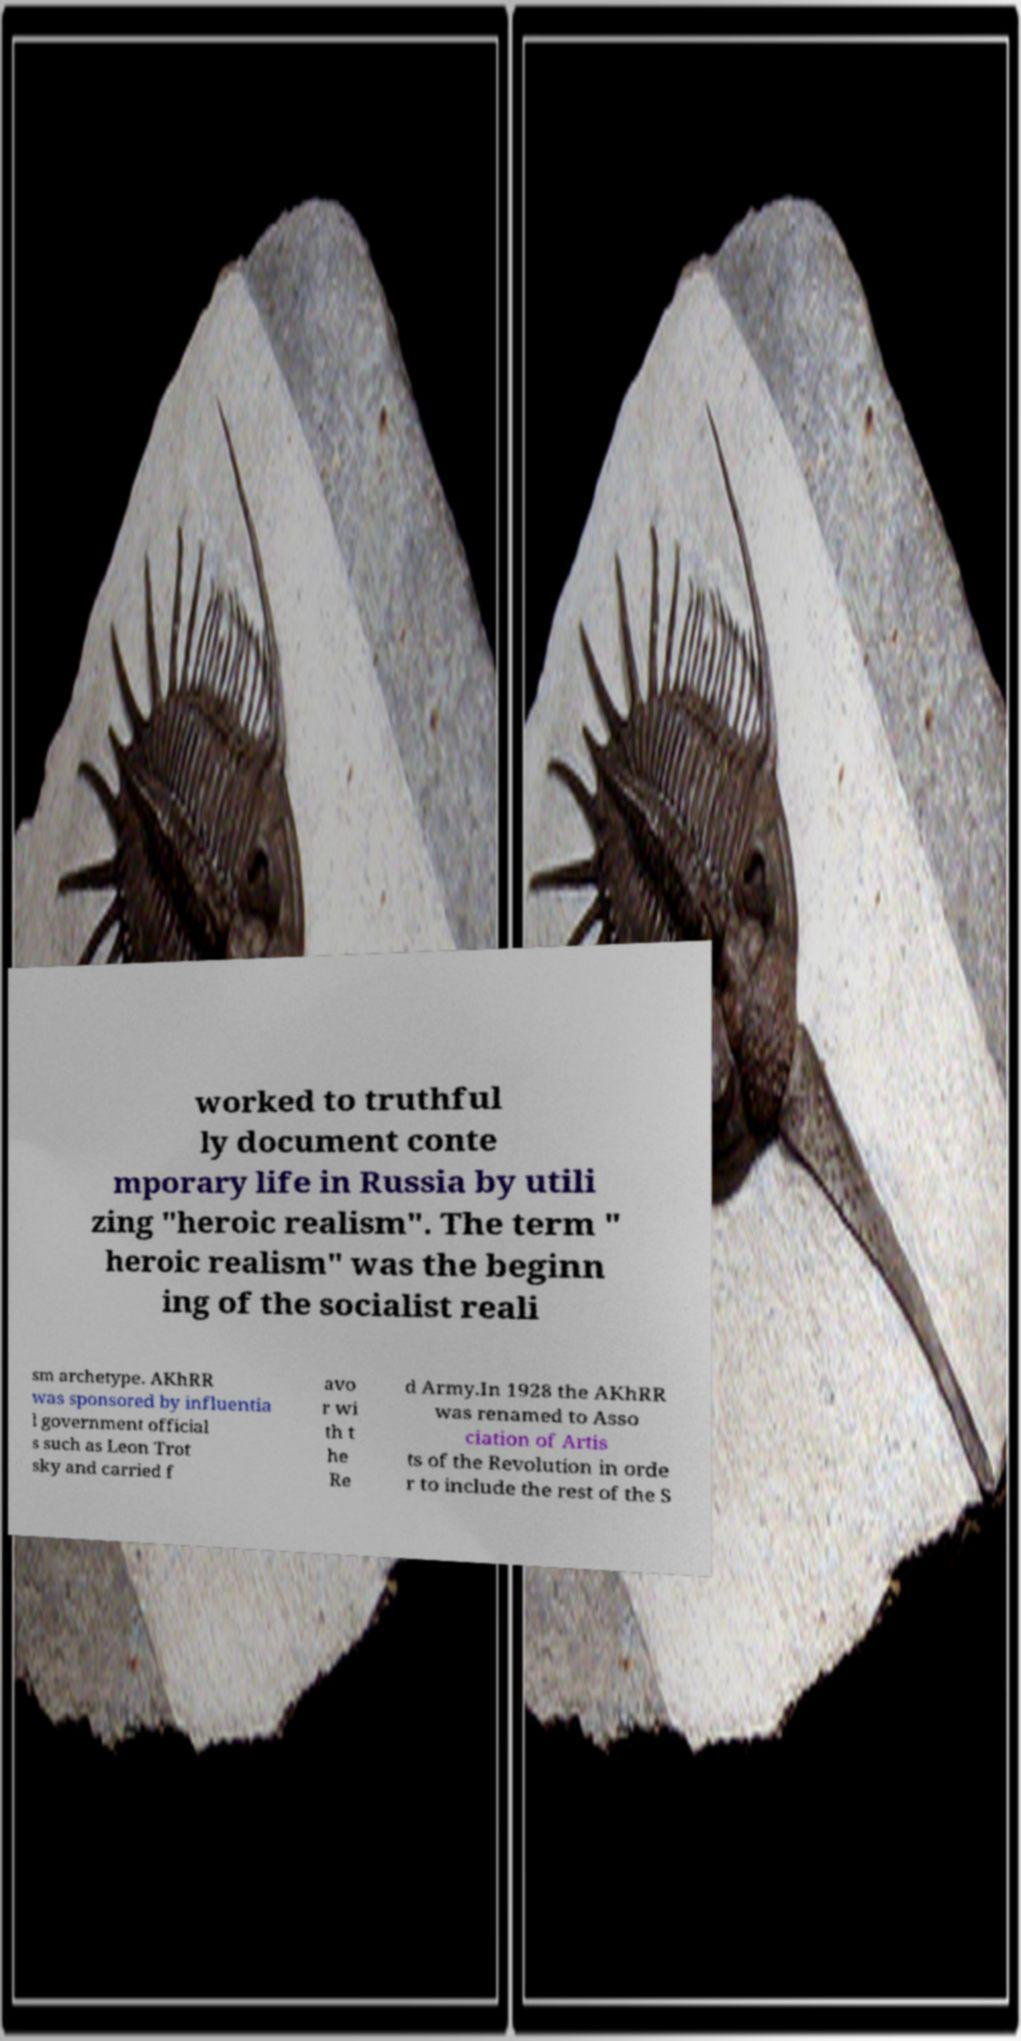Could you assist in decoding the text presented in this image and type it out clearly? worked to truthful ly document conte mporary life in Russia by utili zing "heroic realism". The term " heroic realism" was the beginn ing of the socialist reali sm archetype. AKhRR was sponsored by influentia l government official s such as Leon Trot sky and carried f avo r wi th t he Re d Army.In 1928 the AKhRR was renamed to Asso ciation of Artis ts of the Revolution in orde r to include the rest of the S 